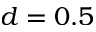<formula> <loc_0><loc_0><loc_500><loc_500>d = 0 . 5</formula> 